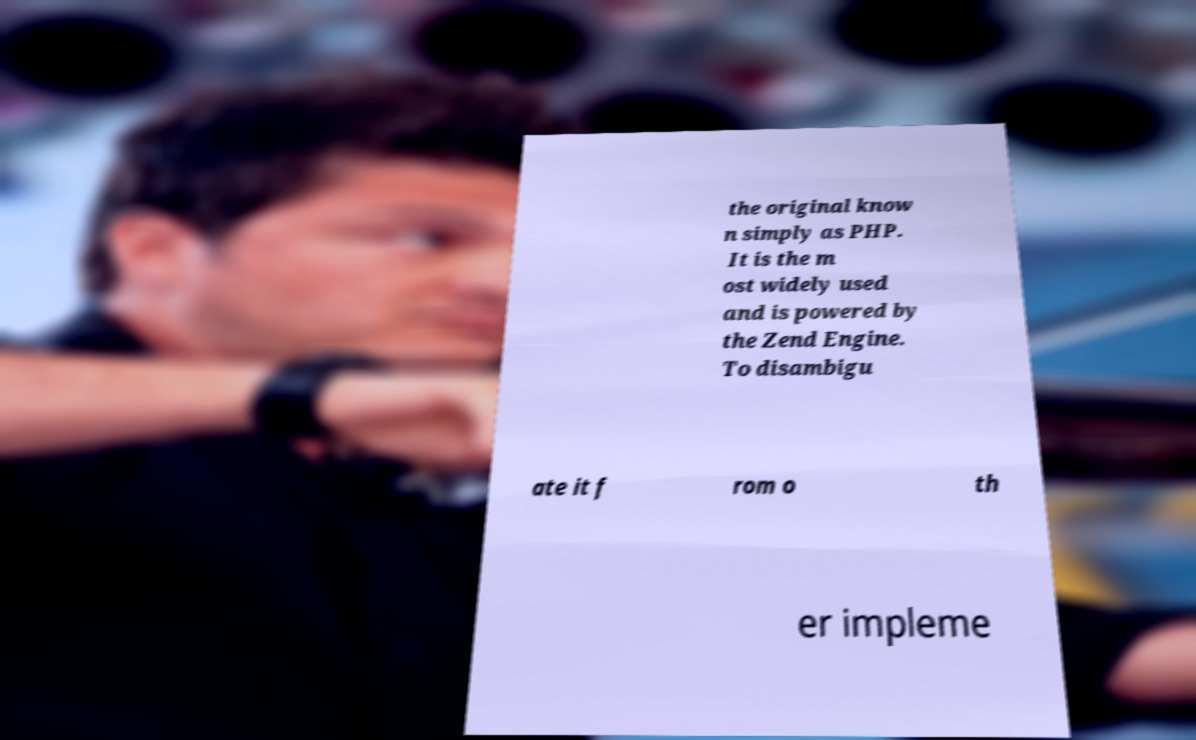Could you extract and type out the text from this image? the original know n simply as PHP. It is the m ost widely used and is powered by the Zend Engine. To disambigu ate it f rom o th er impleme 